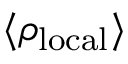Convert formula to latex. <formula><loc_0><loc_0><loc_500><loc_500>\langle \rho _ { l o c a l } \rangle</formula> 